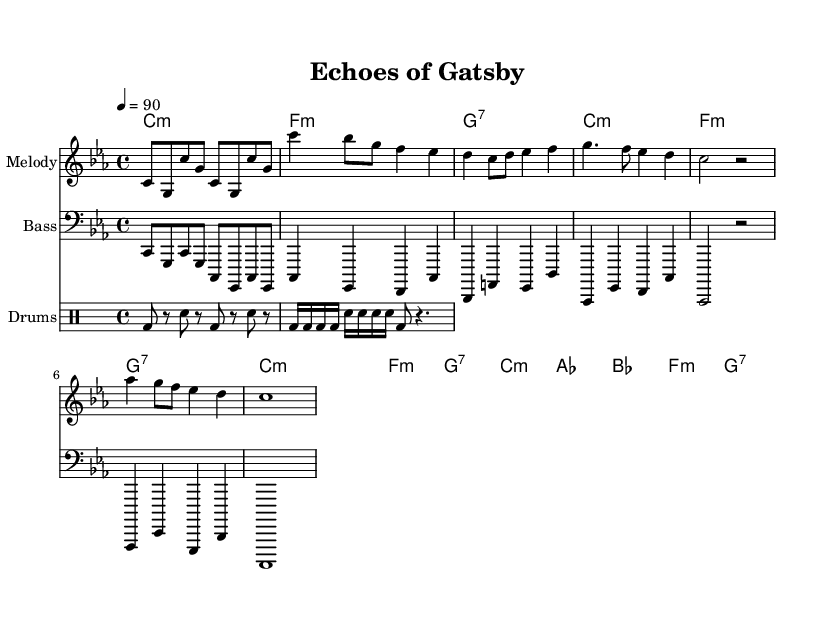What is the key signature of this piece? The key signature is C minor, which has three flats (B♭, E♭, A♭). This can be identified in the beginning of the score.
Answer: C minor What is the time signature of the music? The time signature is 4/4, which indicates that there are four beats per measure, as shown at the beginning of the score.
Answer: 4/4 What is the tempo marking for this piece? The tempo marking is quarter note equals 90, indicating a moderate tempo. This is indicated at the beginning of the score.
Answer: 90 How many measures are in the chorus section? The chorus consists of 4 measures, as can be counted after identifying the division of sections in the score.
Answer: 4 What type of music is this piece categorized as? This piece is categorized as conscious rap, which is evident through its themes drawn from classic literature and contemporary bestsellers indicated in the title "Echoes of Gatsby."
Answer: Conscious rap What is the predominant musical element used in the bridge section? The predominant element is the harmony changes, specifically the shift from A♭ major to B♭ major, which creates a contrast before returning to C minor. This analysis can be conducted by examining the chord progression in the bridge.
Answer: Harmony changes What role does the bass play in this piece? The bass provides a foundational groove and supports the melody, as seen in the bass line that often mirrors the harmonic structure while maintaining the rhythmic integrity necessary for hip hop.
Answer: Foundational groove 